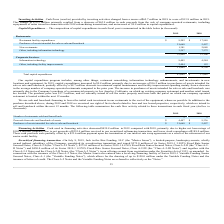According to Jack In The Box's financial document, What is the total capital expenditure in 2019? According to the financial document, $47,649 (in thousands). The relevant text states: "Total capital expenditures $ 47,649 $ 37,842..." Also, What is the increase in capital expenditure from 2018 to 2019? According to the financial document, $9.8 million. The relevant text states: "018 refranchising transactions, and an increase of $9.8 million in capital expenditures...." Also, Why was there an increase in purchases of assets intended for sale or sale and leaseback? Purchase of a commercial property in Los Angeles, California. The document states: "and leaseback was primarily due to the Company’s purchase of a commercial property in Los Angeles, California, on which an existing company restaurant..." Also, can you calculate: What is the difference in restaurant facility expenditures between 2018 and 2019? Based on the calculation: $17,949 - $9,202 , the result is 8747 (in thousands). This is based on the information: "Restaurant facility expenditures $ 9,202 $ 17,949 Restaurant facility expenditures $ 9,202 $ 17,949..." The key data points involved are: 17,949, 9,202. Also, can you calculate: What is the average capital expenditure spent on information technology for 2018 and 2019? To answer this question, I need to perform calculations using the financial data. The calculation is: ($9,405+$4,584)/2 , which equals 6994.5 (in thousands). This is based on the information: "Information technology 9,405 4,584 Information technology 9,405 4,584..." The key data points involved are: 4,584, 9,405. Also, can you calculate: What is the difference in total capital expenditure for restaurants and total capital expenditure for corporate services in 2018? Based on the calculation: $33,106-$4,736, the result is 28370 (in thousands). This is based on the information: "35,840 33,106 11,809 4,736..." The key data points involved are: 33,106, 4,736. 